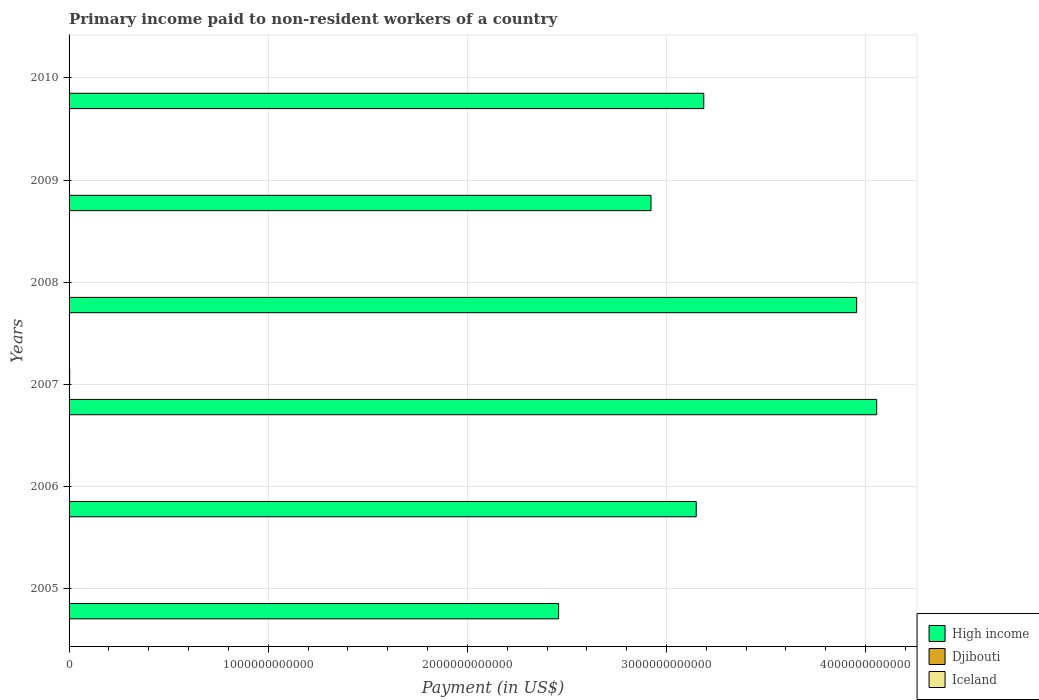Are the number of bars per tick equal to the number of legend labels?
Offer a terse response. Yes. Are the number of bars on each tick of the Y-axis equal?
Keep it short and to the point. Yes. What is the amount paid to workers in Djibouti in 2008?
Ensure brevity in your answer.  4.56e+07. Across all years, what is the maximum amount paid to workers in Iceland?
Offer a terse response. 3.12e+09. Across all years, what is the minimum amount paid to workers in High income?
Ensure brevity in your answer.  2.46e+12. In which year was the amount paid to workers in Djibouti maximum?
Your answer should be very brief. 2008. In which year was the amount paid to workers in Iceland minimum?
Offer a terse response. 2010. What is the total amount paid to workers in High income in the graph?
Make the answer very short. 1.97e+13. What is the difference between the amount paid to workers in Djibouti in 2007 and that in 2009?
Provide a short and direct response. -1.76e+06. What is the difference between the amount paid to workers in Iceland in 2010 and the amount paid to workers in Djibouti in 2009?
Offer a terse response. 3.30e+08. What is the average amount paid to workers in Iceland per year?
Give a very brief answer. 1.50e+09. In the year 2005, what is the difference between the amount paid to workers in High income and amount paid to workers in Djibouti?
Your answer should be very brief. 2.46e+12. What is the ratio of the amount paid to workers in Iceland in 2006 to that in 2010?
Keep it short and to the point. 6.6. Is the amount paid to workers in Iceland in 2005 less than that in 2010?
Ensure brevity in your answer.  No. What is the difference between the highest and the second highest amount paid to workers in High income?
Give a very brief answer. 1.01e+11. What is the difference between the highest and the lowest amount paid to workers in Iceland?
Make the answer very short. 2.76e+09. Is the sum of the amount paid to workers in Djibouti in 2005 and 2006 greater than the maximum amount paid to workers in Iceland across all years?
Keep it short and to the point. No. What does the 2nd bar from the top in 2010 represents?
Your response must be concise. Djibouti. What does the 3rd bar from the bottom in 2008 represents?
Your answer should be compact. Iceland. Is it the case that in every year, the sum of the amount paid to workers in Djibouti and amount paid to workers in Iceland is greater than the amount paid to workers in High income?
Provide a succinct answer. No. What is the difference between two consecutive major ticks on the X-axis?
Your response must be concise. 1.00e+12. Does the graph contain any zero values?
Offer a terse response. No. Does the graph contain grids?
Make the answer very short. Yes. How many legend labels are there?
Offer a terse response. 3. How are the legend labels stacked?
Offer a terse response. Vertical. What is the title of the graph?
Provide a succinct answer. Primary income paid to non-resident workers of a country. Does "Mongolia" appear as one of the legend labels in the graph?
Keep it short and to the point. No. What is the label or title of the X-axis?
Ensure brevity in your answer.  Payment (in US$). What is the label or title of the Y-axis?
Your response must be concise. Years. What is the Payment (in US$) of High income in 2005?
Offer a terse response. 2.46e+12. What is the Payment (in US$) in Djibouti in 2005?
Offer a very short reply. 3.20e+07. What is the Payment (in US$) in Iceland in 2005?
Your answer should be very brief. 1.34e+09. What is the Payment (in US$) in High income in 2006?
Give a very brief answer. 3.15e+12. What is the Payment (in US$) of Djibouti in 2006?
Your answer should be compact. 3.49e+07. What is the Payment (in US$) of Iceland in 2006?
Your answer should be very brief. 2.42e+09. What is the Payment (in US$) in High income in 2007?
Offer a terse response. 4.06e+12. What is the Payment (in US$) in Djibouti in 2007?
Give a very brief answer. 3.52e+07. What is the Payment (in US$) in Iceland in 2007?
Give a very brief answer. 3.12e+09. What is the Payment (in US$) in High income in 2008?
Your answer should be very brief. 3.95e+12. What is the Payment (in US$) of Djibouti in 2008?
Offer a terse response. 4.56e+07. What is the Payment (in US$) of Iceland in 2008?
Give a very brief answer. 1.22e+09. What is the Payment (in US$) in High income in 2009?
Ensure brevity in your answer.  2.92e+12. What is the Payment (in US$) of Djibouti in 2009?
Keep it short and to the point. 3.70e+07. What is the Payment (in US$) in Iceland in 2009?
Keep it short and to the point. 5.46e+08. What is the Payment (in US$) in High income in 2010?
Keep it short and to the point. 3.19e+12. What is the Payment (in US$) of Djibouti in 2010?
Keep it short and to the point. 3.28e+07. What is the Payment (in US$) in Iceland in 2010?
Provide a succinct answer. 3.67e+08. Across all years, what is the maximum Payment (in US$) of High income?
Your answer should be compact. 4.06e+12. Across all years, what is the maximum Payment (in US$) of Djibouti?
Your answer should be compact. 4.56e+07. Across all years, what is the maximum Payment (in US$) of Iceland?
Your response must be concise. 3.12e+09. Across all years, what is the minimum Payment (in US$) of High income?
Offer a terse response. 2.46e+12. Across all years, what is the minimum Payment (in US$) of Djibouti?
Ensure brevity in your answer.  3.20e+07. Across all years, what is the minimum Payment (in US$) of Iceland?
Provide a short and direct response. 3.67e+08. What is the total Payment (in US$) in High income in the graph?
Provide a succinct answer. 1.97e+13. What is the total Payment (in US$) in Djibouti in the graph?
Make the answer very short. 2.17e+08. What is the total Payment (in US$) in Iceland in the graph?
Your answer should be compact. 9.01e+09. What is the difference between the Payment (in US$) in High income in 2005 and that in 2006?
Your answer should be compact. -6.91e+11. What is the difference between the Payment (in US$) of Djibouti in 2005 and that in 2006?
Your answer should be compact. -2.91e+06. What is the difference between the Payment (in US$) of Iceland in 2005 and that in 2006?
Offer a very short reply. -1.08e+09. What is the difference between the Payment (in US$) in High income in 2005 and that in 2007?
Give a very brief answer. -1.60e+12. What is the difference between the Payment (in US$) in Djibouti in 2005 and that in 2007?
Provide a short and direct response. -3.24e+06. What is the difference between the Payment (in US$) in Iceland in 2005 and that in 2007?
Provide a short and direct response. -1.79e+09. What is the difference between the Payment (in US$) of High income in 2005 and that in 2008?
Ensure brevity in your answer.  -1.50e+12. What is the difference between the Payment (in US$) in Djibouti in 2005 and that in 2008?
Provide a succinct answer. -1.36e+07. What is the difference between the Payment (in US$) of Iceland in 2005 and that in 2008?
Ensure brevity in your answer.  1.20e+08. What is the difference between the Payment (in US$) of High income in 2005 and that in 2009?
Ensure brevity in your answer.  -4.64e+11. What is the difference between the Payment (in US$) in Djibouti in 2005 and that in 2009?
Your answer should be compact. -5.00e+06. What is the difference between the Payment (in US$) in Iceland in 2005 and that in 2009?
Keep it short and to the point. 7.92e+08. What is the difference between the Payment (in US$) of High income in 2005 and that in 2010?
Your answer should be very brief. -7.29e+11. What is the difference between the Payment (in US$) in Djibouti in 2005 and that in 2010?
Make the answer very short. -7.99e+05. What is the difference between the Payment (in US$) in Iceland in 2005 and that in 2010?
Your answer should be very brief. 9.72e+08. What is the difference between the Payment (in US$) of High income in 2006 and that in 2007?
Make the answer very short. -9.06e+11. What is the difference between the Payment (in US$) in Djibouti in 2006 and that in 2007?
Your response must be concise. -3.32e+05. What is the difference between the Payment (in US$) of Iceland in 2006 and that in 2007?
Offer a terse response. -7.04e+08. What is the difference between the Payment (in US$) of High income in 2006 and that in 2008?
Keep it short and to the point. -8.06e+11. What is the difference between the Payment (in US$) of Djibouti in 2006 and that in 2008?
Your response must be concise. -1.07e+07. What is the difference between the Payment (in US$) in Iceland in 2006 and that in 2008?
Your response must be concise. 1.20e+09. What is the difference between the Payment (in US$) in High income in 2006 and that in 2009?
Give a very brief answer. 2.27e+11. What is the difference between the Payment (in US$) in Djibouti in 2006 and that in 2009?
Give a very brief answer. -2.09e+06. What is the difference between the Payment (in US$) of Iceland in 2006 and that in 2009?
Provide a short and direct response. 1.87e+09. What is the difference between the Payment (in US$) in High income in 2006 and that in 2010?
Your response must be concise. -3.80e+1. What is the difference between the Payment (in US$) of Djibouti in 2006 and that in 2010?
Make the answer very short. 2.11e+06. What is the difference between the Payment (in US$) of Iceland in 2006 and that in 2010?
Provide a short and direct response. 2.05e+09. What is the difference between the Payment (in US$) of High income in 2007 and that in 2008?
Give a very brief answer. 1.01e+11. What is the difference between the Payment (in US$) of Djibouti in 2007 and that in 2008?
Offer a terse response. -1.04e+07. What is the difference between the Payment (in US$) of Iceland in 2007 and that in 2008?
Your answer should be compact. 1.91e+09. What is the difference between the Payment (in US$) in High income in 2007 and that in 2009?
Your answer should be very brief. 1.13e+12. What is the difference between the Payment (in US$) of Djibouti in 2007 and that in 2009?
Offer a terse response. -1.76e+06. What is the difference between the Payment (in US$) of Iceland in 2007 and that in 2009?
Ensure brevity in your answer.  2.58e+09. What is the difference between the Payment (in US$) of High income in 2007 and that in 2010?
Your response must be concise. 8.68e+11. What is the difference between the Payment (in US$) of Djibouti in 2007 and that in 2010?
Provide a succinct answer. 2.44e+06. What is the difference between the Payment (in US$) in Iceland in 2007 and that in 2010?
Provide a short and direct response. 2.76e+09. What is the difference between the Payment (in US$) of High income in 2008 and that in 2009?
Give a very brief answer. 1.03e+12. What is the difference between the Payment (in US$) of Djibouti in 2008 and that in 2009?
Give a very brief answer. 8.63e+06. What is the difference between the Payment (in US$) of Iceland in 2008 and that in 2009?
Your answer should be very brief. 6.72e+08. What is the difference between the Payment (in US$) of High income in 2008 and that in 2010?
Your answer should be very brief. 7.68e+11. What is the difference between the Payment (in US$) in Djibouti in 2008 and that in 2010?
Provide a succinct answer. 1.28e+07. What is the difference between the Payment (in US$) of Iceland in 2008 and that in 2010?
Keep it short and to the point. 8.52e+08. What is the difference between the Payment (in US$) of High income in 2009 and that in 2010?
Your answer should be compact. -2.65e+11. What is the difference between the Payment (in US$) of Djibouti in 2009 and that in 2010?
Provide a short and direct response. 4.20e+06. What is the difference between the Payment (in US$) in Iceland in 2009 and that in 2010?
Keep it short and to the point. 1.80e+08. What is the difference between the Payment (in US$) of High income in 2005 and the Payment (in US$) of Djibouti in 2006?
Offer a very short reply. 2.46e+12. What is the difference between the Payment (in US$) in High income in 2005 and the Payment (in US$) in Iceland in 2006?
Your response must be concise. 2.46e+12. What is the difference between the Payment (in US$) in Djibouti in 2005 and the Payment (in US$) in Iceland in 2006?
Give a very brief answer. -2.39e+09. What is the difference between the Payment (in US$) in High income in 2005 and the Payment (in US$) in Djibouti in 2007?
Your answer should be very brief. 2.46e+12. What is the difference between the Payment (in US$) of High income in 2005 and the Payment (in US$) of Iceland in 2007?
Your response must be concise. 2.46e+12. What is the difference between the Payment (in US$) of Djibouti in 2005 and the Payment (in US$) of Iceland in 2007?
Provide a short and direct response. -3.09e+09. What is the difference between the Payment (in US$) in High income in 2005 and the Payment (in US$) in Djibouti in 2008?
Make the answer very short. 2.46e+12. What is the difference between the Payment (in US$) in High income in 2005 and the Payment (in US$) in Iceland in 2008?
Ensure brevity in your answer.  2.46e+12. What is the difference between the Payment (in US$) of Djibouti in 2005 and the Payment (in US$) of Iceland in 2008?
Your answer should be compact. -1.19e+09. What is the difference between the Payment (in US$) of High income in 2005 and the Payment (in US$) of Djibouti in 2009?
Ensure brevity in your answer.  2.46e+12. What is the difference between the Payment (in US$) of High income in 2005 and the Payment (in US$) of Iceland in 2009?
Keep it short and to the point. 2.46e+12. What is the difference between the Payment (in US$) of Djibouti in 2005 and the Payment (in US$) of Iceland in 2009?
Your answer should be compact. -5.14e+08. What is the difference between the Payment (in US$) of High income in 2005 and the Payment (in US$) of Djibouti in 2010?
Provide a succinct answer. 2.46e+12. What is the difference between the Payment (in US$) of High income in 2005 and the Payment (in US$) of Iceland in 2010?
Offer a very short reply. 2.46e+12. What is the difference between the Payment (in US$) of Djibouti in 2005 and the Payment (in US$) of Iceland in 2010?
Make the answer very short. -3.35e+08. What is the difference between the Payment (in US$) of High income in 2006 and the Payment (in US$) of Djibouti in 2007?
Ensure brevity in your answer.  3.15e+12. What is the difference between the Payment (in US$) of High income in 2006 and the Payment (in US$) of Iceland in 2007?
Ensure brevity in your answer.  3.15e+12. What is the difference between the Payment (in US$) in Djibouti in 2006 and the Payment (in US$) in Iceland in 2007?
Give a very brief answer. -3.09e+09. What is the difference between the Payment (in US$) of High income in 2006 and the Payment (in US$) of Djibouti in 2008?
Your answer should be very brief. 3.15e+12. What is the difference between the Payment (in US$) in High income in 2006 and the Payment (in US$) in Iceland in 2008?
Keep it short and to the point. 3.15e+12. What is the difference between the Payment (in US$) of Djibouti in 2006 and the Payment (in US$) of Iceland in 2008?
Offer a very short reply. -1.18e+09. What is the difference between the Payment (in US$) in High income in 2006 and the Payment (in US$) in Djibouti in 2009?
Give a very brief answer. 3.15e+12. What is the difference between the Payment (in US$) in High income in 2006 and the Payment (in US$) in Iceland in 2009?
Your response must be concise. 3.15e+12. What is the difference between the Payment (in US$) in Djibouti in 2006 and the Payment (in US$) in Iceland in 2009?
Ensure brevity in your answer.  -5.12e+08. What is the difference between the Payment (in US$) in High income in 2006 and the Payment (in US$) in Djibouti in 2010?
Your answer should be compact. 3.15e+12. What is the difference between the Payment (in US$) in High income in 2006 and the Payment (in US$) in Iceland in 2010?
Offer a very short reply. 3.15e+12. What is the difference between the Payment (in US$) of Djibouti in 2006 and the Payment (in US$) of Iceland in 2010?
Offer a very short reply. -3.32e+08. What is the difference between the Payment (in US$) in High income in 2007 and the Payment (in US$) in Djibouti in 2008?
Offer a terse response. 4.06e+12. What is the difference between the Payment (in US$) of High income in 2007 and the Payment (in US$) of Iceland in 2008?
Provide a succinct answer. 4.05e+12. What is the difference between the Payment (in US$) of Djibouti in 2007 and the Payment (in US$) of Iceland in 2008?
Give a very brief answer. -1.18e+09. What is the difference between the Payment (in US$) in High income in 2007 and the Payment (in US$) in Djibouti in 2009?
Your answer should be compact. 4.06e+12. What is the difference between the Payment (in US$) of High income in 2007 and the Payment (in US$) of Iceland in 2009?
Provide a succinct answer. 4.05e+12. What is the difference between the Payment (in US$) in Djibouti in 2007 and the Payment (in US$) in Iceland in 2009?
Keep it short and to the point. -5.11e+08. What is the difference between the Payment (in US$) in High income in 2007 and the Payment (in US$) in Djibouti in 2010?
Give a very brief answer. 4.06e+12. What is the difference between the Payment (in US$) in High income in 2007 and the Payment (in US$) in Iceland in 2010?
Your answer should be very brief. 4.06e+12. What is the difference between the Payment (in US$) in Djibouti in 2007 and the Payment (in US$) in Iceland in 2010?
Offer a very short reply. -3.32e+08. What is the difference between the Payment (in US$) of High income in 2008 and the Payment (in US$) of Djibouti in 2009?
Offer a terse response. 3.95e+12. What is the difference between the Payment (in US$) of High income in 2008 and the Payment (in US$) of Iceland in 2009?
Your answer should be very brief. 3.95e+12. What is the difference between the Payment (in US$) in Djibouti in 2008 and the Payment (in US$) in Iceland in 2009?
Your response must be concise. -5.01e+08. What is the difference between the Payment (in US$) in High income in 2008 and the Payment (in US$) in Djibouti in 2010?
Give a very brief answer. 3.95e+12. What is the difference between the Payment (in US$) in High income in 2008 and the Payment (in US$) in Iceland in 2010?
Make the answer very short. 3.95e+12. What is the difference between the Payment (in US$) of Djibouti in 2008 and the Payment (in US$) of Iceland in 2010?
Offer a very short reply. -3.21e+08. What is the difference between the Payment (in US$) of High income in 2009 and the Payment (in US$) of Djibouti in 2010?
Make the answer very short. 2.92e+12. What is the difference between the Payment (in US$) in High income in 2009 and the Payment (in US$) in Iceland in 2010?
Give a very brief answer. 2.92e+12. What is the difference between the Payment (in US$) of Djibouti in 2009 and the Payment (in US$) of Iceland in 2010?
Ensure brevity in your answer.  -3.30e+08. What is the average Payment (in US$) in High income per year?
Your response must be concise. 3.29e+12. What is the average Payment (in US$) of Djibouti per year?
Offer a terse response. 3.62e+07. What is the average Payment (in US$) in Iceland per year?
Your answer should be very brief. 1.50e+09. In the year 2005, what is the difference between the Payment (in US$) of High income and Payment (in US$) of Djibouti?
Ensure brevity in your answer.  2.46e+12. In the year 2005, what is the difference between the Payment (in US$) in High income and Payment (in US$) in Iceland?
Give a very brief answer. 2.46e+12. In the year 2005, what is the difference between the Payment (in US$) of Djibouti and Payment (in US$) of Iceland?
Keep it short and to the point. -1.31e+09. In the year 2006, what is the difference between the Payment (in US$) of High income and Payment (in US$) of Djibouti?
Give a very brief answer. 3.15e+12. In the year 2006, what is the difference between the Payment (in US$) in High income and Payment (in US$) in Iceland?
Offer a terse response. 3.15e+12. In the year 2006, what is the difference between the Payment (in US$) of Djibouti and Payment (in US$) of Iceland?
Offer a terse response. -2.39e+09. In the year 2007, what is the difference between the Payment (in US$) of High income and Payment (in US$) of Djibouti?
Keep it short and to the point. 4.06e+12. In the year 2007, what is the difference between the Payment (in US$) in High income and Payment (in US$) in Iceland?
Offer a very short reply. 4.05e+12. In the year 2007, what is the difference between the Payment (in US$) of Djibouti and Payment (in US$) of Iceland?
Your response must be concise. -3.09e+09. In the year 2008, what is the difference between the Payment (in US$) of High income and Payment (in US$) of Djibouti?
Provide a succinct answer. 3.95e+12. In the year 2008, what is the difference between the Payment (in US$) of High income and Payment (in US$) of Iceland?
Provide a short and direct response. 3.95e+12. In the year 2008, what is the difference between the Payment (in US$) of Djibouti and Payment (in US$) of Iceland?
Ensure brevity in your answer.  -1.17e+09. In the year 2009, what is the difference between the Payment (in US$) in High income and Payment (in US$) in Djibouti?
Your answer should be very brief. 2.92e+12. In the year 2009, what is the difference between the Payment (in US$) of High income and Payment (in US$) of Iceland?
Your answer should be very brief. 2.92e+12. In the year 2009, what is the difference between the Payment (in US$) of Djibouti and Payment (in US$) of Iceland?
Your answer should be very brief. -5.09e+08. In the year 2010, what is the difference between the Payment (in US$) of High income and Payment (in US$) of Djibouti?
Give a very brief answer. 3.19e+12. In the year 2010, what is the difference between the Payment (in US$) of High income and Payment (in US$) of Iceland?
Provide a succinct answer. 3.19e+12. In the year 2010, what is the difference between the Payment (in US$) in Djibouti and Payment (in US$) in Iceland?
Your answer should be compact. -3.34e+08. What is the ratio of the Payment (in US$) of High income in 2005 to that in 2006?
Give a very brief answer. 0.78. What is the ratio of the Payment (in US$) of Djibouti in 2005 to that in 2006?
Your response must be concise. 0.92. What is the ratio of the Payment (in US$) of Iceland in 2005 to that in 2006?
Provide a short and direct response. 0.55. What is the ratio of the Payment (in US$) in High income in 2005 to that in 2007?
Provide a short and direct response. 0.61. What is the ratio of the Payment (in US$) of Djibouti in 2005 to that in 2007?
Your answer should be compact. 0.91. What is the ratio of the Payment (in US$) of Iceland in 2005 to that in 2007?
Your answer should be compact. 0.43. What is the ratio of the Payment (in US$) of High income in 2005 to that in 2008?
Your answer should be compact. 0.62. What is the ratio of the Payment (in US$) of Djibouti in 2005 to that in 2008?
Provide a short and direct response. 0.7. What is the ratio of the Payment (in US$) of Iceland in 2005 to that in 2008?
Keep it short and to the point. 1.1. What is the ratio of the Payment (in US$) in High income in 2005 to that in 2009?
Your answer should be very brief. 0.84. What is the ratio of the Payment (in US$) in Djibouti in 2005 to that in 2009?
Your answer should be very brief. 0.86. What is the ratio of the Payment (in US$) of Iceland in 2005 to that in 2009?
Make the answer very short. 2.45. What is the ratio of the Payment (in US$) in High income in 2005 to that in 2010?
Give a very brief answer. 0.77. What is the ratio of the Payment (in US$) of Djibouti in 2005 to that in 2010?
Your answer should be compact. 0.98. What is the ratio of the Payment (in US$) in Iceland in 2005 to that in 2010?
Provide a short and direct response. 3.65. What is the ratio of the Payment (in US$) of High income in 2006 to that in 2007?
Your answer should be compact. 0.78. What is the ratio of the Payment (in US$) in Djibouti in 2006 to that in 2007?
Provide a succinct answer. 0.99. What is the ratio of the Payment (in US$) in Iceland in 2006 to that in 2007?
Offer a very short reply. 0.77. What is the ratio of the Payment (in US$) of High income in 2006 to that in 2008?
Your answer should be very brief. 0.8. What is the ratio of the Payment (in US$) in Djibouti in 2006 to that in 2008?
Give a very brief answer. 0.76. What is the ratio of the Payment (in US$) of Iceland in 2006 to that in 2008?
Keep it short and to the point. 1.99. What is the ratio of the Payment (in US$) of High income in 2006 to that in 2009?
Keep it short and to the point. 1.08. What is the ratio of the Payment (in US$) in Djibouti in 2006 to that in 2009?
Give a very brief answer. 0.94. What is the ratio of the Payment (in US$) in Iceland in 2006 to that in 2009?
Your answer should be compact. 4.43. What is the ratio of the Payment (in US$) in High income in 2006 to that in 2010?
Keep it short and to the point. 0.99. What is the ratio of the Payment (in US$) of Djibouti in 2006 to that in 2010?
Give a very brief answer. 1.06. What is the ratio of the Payment (in US$) of Iceland in 2006 to that in 2010?
Provide a short and direct response. 6.6. What is the ratio of the Payment (in US$) of High income in 2007 to that in 2008?
Your answer should be very brief. 1.03. What is the ratio of the Payment (in US$) of Djibouti in 2007 to that in 2008?
Your answer should be compact. 0.77. What is the ratio of the Payment (in US$) in Iceland in 2007 to that in 2008?
Your answer should be compact. 2.56. What is the ratio of the Payment (in US$) of High income in 2007 to that in 2009?
Provide a short and direct response. 1.39. What is the ratio of the Payment (in US$) in Djibouti in 2007 to that in 2009?
Offer a very short reply. 0.95. What is the ratio of the Payment (in US$) in Iceland in 2007 to that in 2009?
Your answer should be very brief. 5.72. What is the ratio of the Payment (in US$) of High income in 2007 to that in 2010?
Your response must be concise. 1.27. What is the ratio of the Payment (in US$) of Djibouti in 2007 to that in 2010?
Offer a terse response. 1.07. What is the ratio of the Payment (in US$) of Iceland in 2007 to that in 2010?
Your response must be concise. 8.52. What is the ratio of the Payment (in US$) of High income in 2008 to that in 2009?
Ensure brevity in your answer.  1.35. What is the ratio of the Payment (in US$) in Djibouti in 2008 to that in 2009?
Make the answer very short. 1.23. What is the ratio of the Payment (in US$) of Iceland in 2008 to that in 2009?
Provide a short and direct response. 2.23. What is the ratio of the Payment (in US$) in High income in 2008 to that in 2010?
Offer a very short reply. 1.24. What is the ratio of the Payment (in US$) of Djibouti in 2008 to that in 2010?
Your response must be concise. 1.39. What is the ratio of the Payment (in US$) of Iceland in 2008 to that in 2010?
Offer a very short reply. 3.32. What is the ratio of the Payment (in US$) in High income in 2009 to that in 2010?
Your answer should be compact. 0.92. What is the ratio of the Payment (in US$) in Djibouti in 2009 to that in 2010?
Make the answer very short. 1.13. What is the ratio of the Payment (in US$) of Iceland in 2009 to that in 2010?
Keep it short and to the point. 1.49. What is the difference between the highest and the second highest Payment (in US$) of High income?
Your answer should be very brief. 1.01e+11. What is the difference between the highest and the second highest Payment (in US$) in Djibouti?
Offer a terse response. 8.63e+06. What is the difference between the highest and the second highest Payment (in US$) in Iceland?
Provide a short and direct response. 7.04e+08. What is the difference between the highest and the lowest Payment (in US$) in High income?
Ensure brevity in your answer.  1.60e+12. What is the difference between the highest and the lowest Payment (in US$) of Djibouti?
Ensure brevity in your answer.  1.36e+07. What is the difference between the highest and the lowest Payment (in US$) in Iceland?
Offer a terse response. 2.76e+09. 